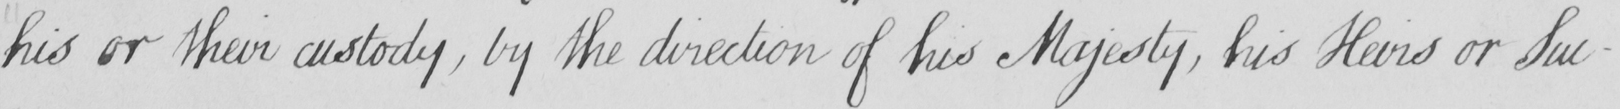What does this handwritten line say? his or their custody  , by the direction of his Majesty , his Heirs or Suc- 